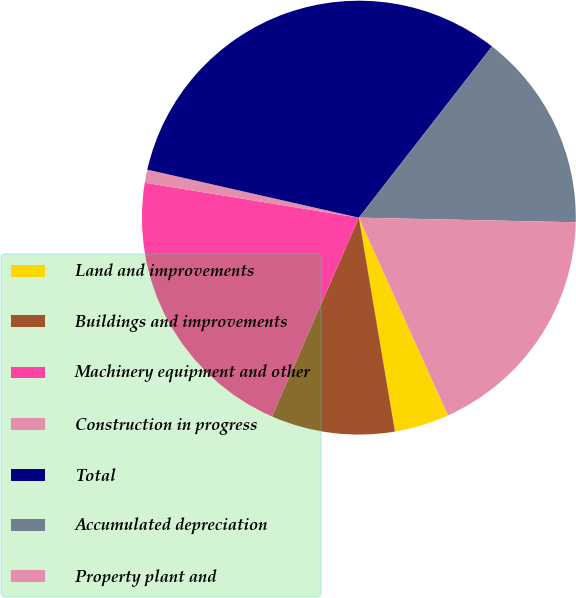Convert chart to OTSL. <chart><loc_0><loc_0><loc_500><loc_500><pie_chart><fcel>Land and improvements<fcel>Buildings and improvements<fcel>Machinery equipment and other<fcel>Construction in progress<fcel>Total<fcel>Accumulated depreciation<fcel>Property plant and<nl><fcel>4.08%<fcel>9.21%<fcel>21.02%<fcel>0.98%<fcel>31.96%<fcel>14.82%<fcel>17.92%<nl></chart> 